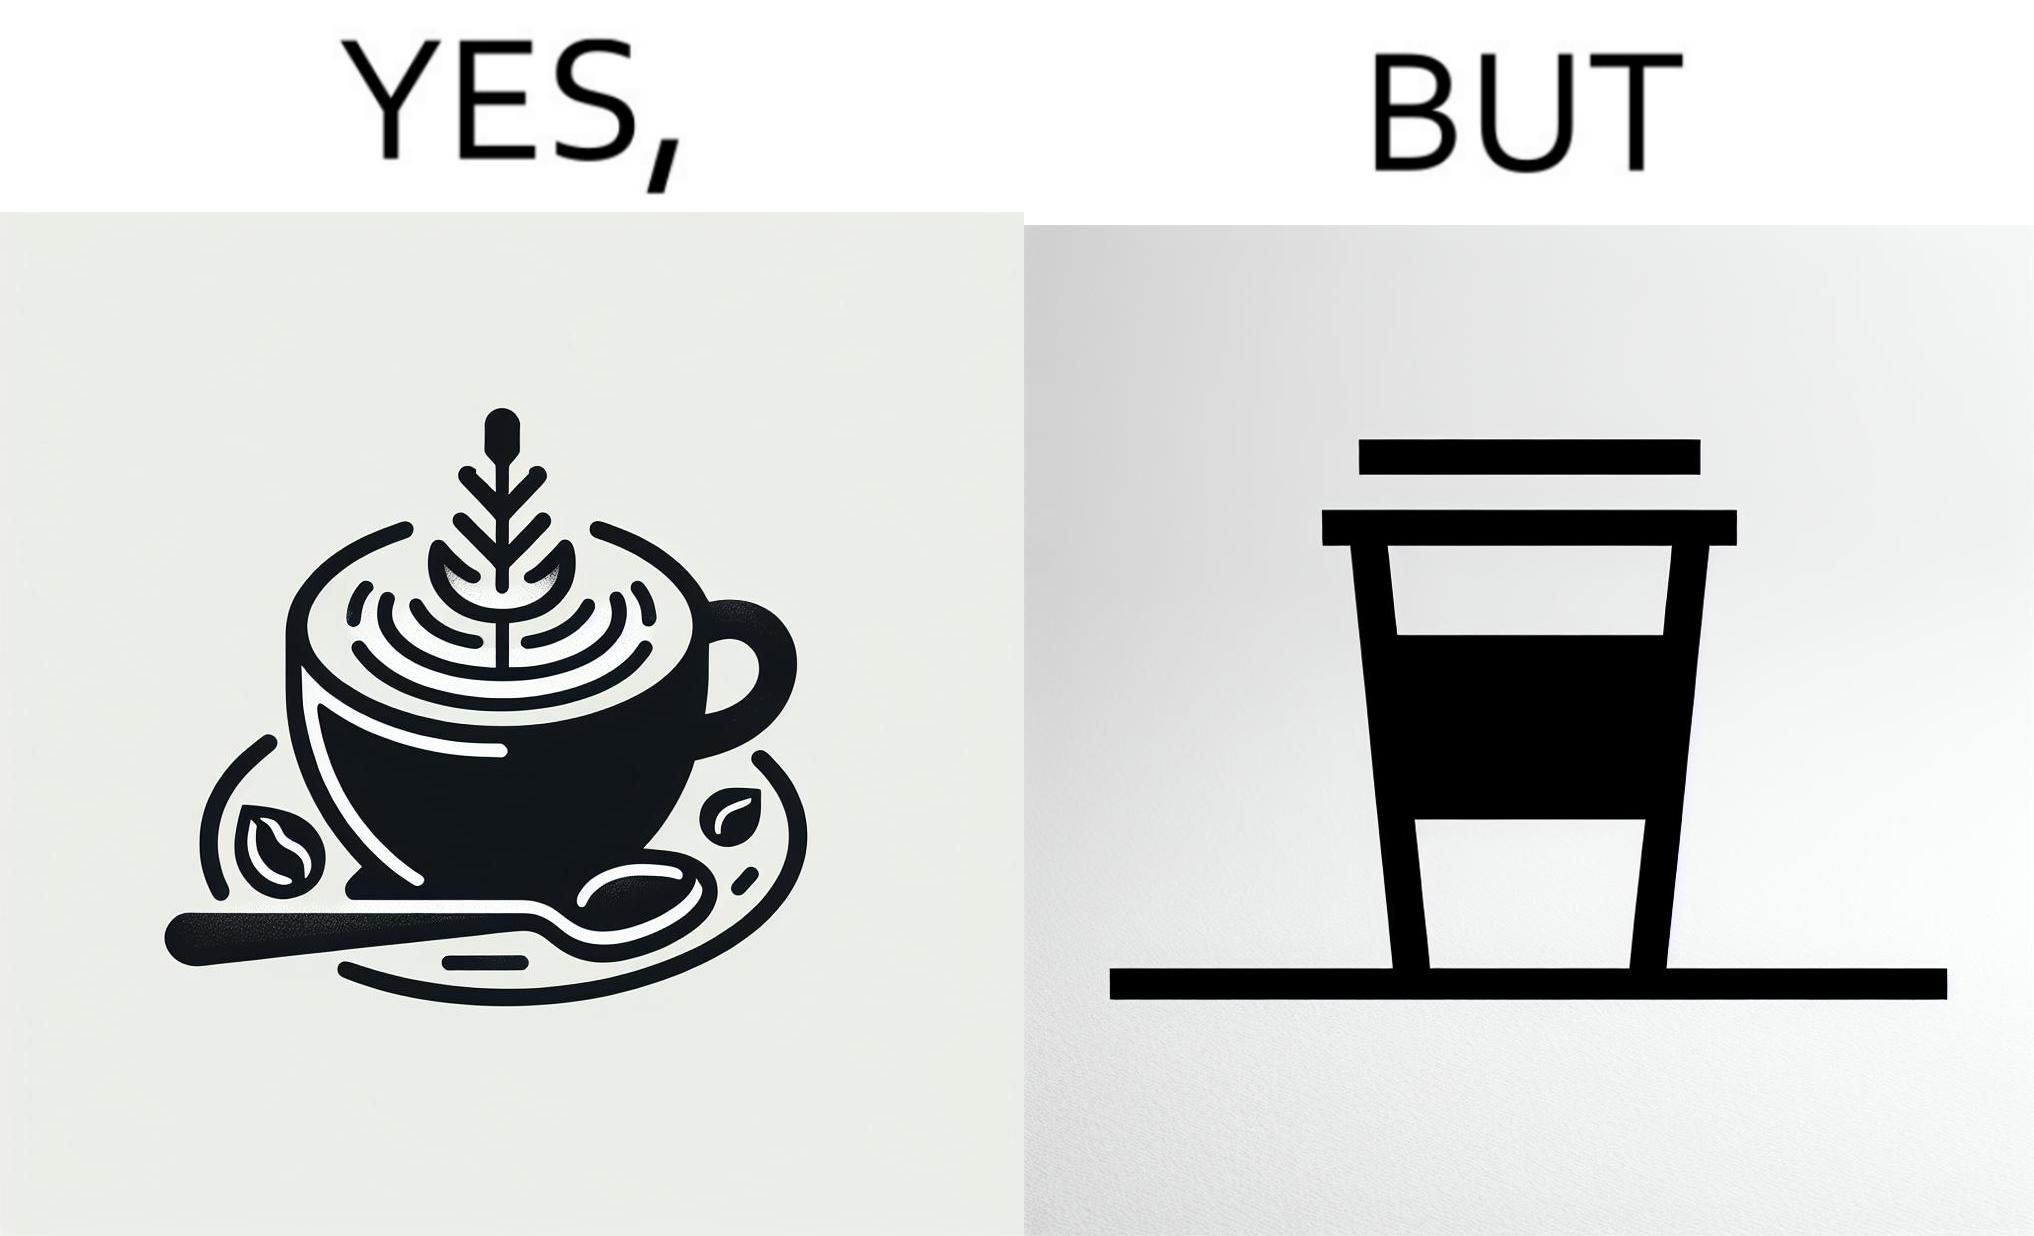Is this image satirical or non-satirical? Yes, this image is satirical. 